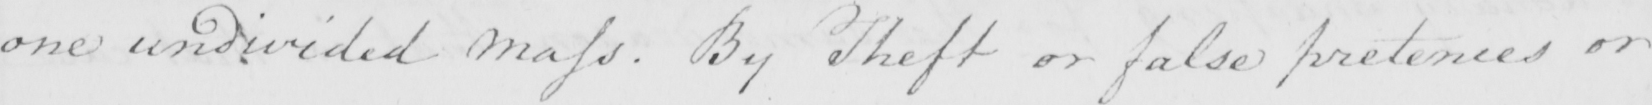Please transcribe the handwritten text in this image. one undivided Mass . By Theft or false pretences or 